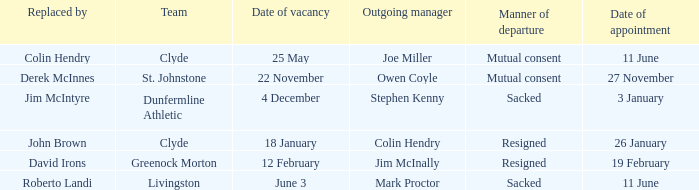Tell me the outgoing manager for 22 november date of vacancy Owen Coyle. 